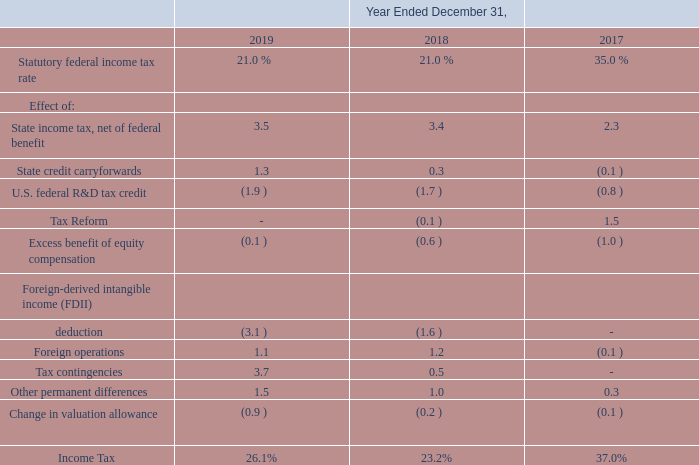We present below a summary of the items that cause recorded income taxes to differ from taxes computed using the statutory
federal income tax rate for the years ended December 31, 2019, 2018 and 2017:
On December 22, 2017, the United States enacted tax reform legislation commonly known as the Tax Cuts and Jobs Act (“the Act”), resulting in significant modifications to existing law. In December 2017, we recorded a provisional estimate of $3.3 million for the one-time deemed repatriation transition tax on unrepatriated foreign earnings. The provisional amount was based on information available at that time, including estimated tax earnings and profits from foreign investments. In the fourth quarter of 2018, we finalized our transition tax calculation and recorded additional tax expense of $0.3 million. In December 2017, we also recorded a provisional write-down to deferred tax assets of $0.7 million related to changes in Section 162(m), Internal Revenue Code of 1986, regarding deductions for excessive employee compensation. In 2018, we finalized our calculation under Section 162(m) and recorded a tax benefit of $0.5 million. We also recorded a one-time tax benefit in December 2017 of $1.2 million from the remeasurement of deferred tax assets and liabilities from 35% to 21%. As of December 31, 2018, we completed the accounting for all of the impacts of the Act. Act”), resulting in significant modifications to existing law. In December 2017, we recorded a provisional estimate of $3.3 million for the one-time deemed repatriation transition tax on unrepatriated foreign earnings. The provisional amount was based on information available at that time, including estimated tax earnings and profits from foreign investments. In the fourth quarter of 2018, we finalized our transition tax calculation and recorded additional tax expense of $0.3 million. In December 2017, we also recorded a provisional write-down to deferred tax assets of $0.7 million related to changes in Section 162(m), Internal Revenue Code of 1986, regarding deductions for excessive employee compensation. In 2018, we finalized our calculation under Section 162(m) and recorded a tax benefit of $0.5 million. We also recorded a one-time tax benefit in December 2017 of $1.2 million from the remeasurement of deferred tax assets and liabilities from 35% to 21%. As of December 31, 2018, we completed the accounting for all of the impacts of the Act.
Act”), resulting in significant modifications to existing law. In December 2017, we recorded a provisional estimate of $3.3 million for
the one-time deemed repatriation transition tax on unrepatriated foreign earnings. The provisional amount was based on information
available at that time, including estimated tax earnings and profits from foreign investments. In the fourth quarter of 2018, we
finalized our transition tax calculation and recorded additional tax expense of $0.3 million. In December 2017, we also recorded a
provisional write-down to deferred tax assets of $0.7 million related to changes in Section 162(m), Internal Revenue Code of 1986,
regarding deductions for excessive employee compensation. In 2018, we finalized our calculation under Section 162(m) and recorded
a tax benefit of $0.5 million. We also recorded a one-time tax benefit in December 2017 of $1.2 million from the remeasurement of
deferred tax assets and liabilities from 35% to 21%. As of December 31, 2018, we completed the accounting for all of the impacts of
the Act.
The Act provides for the global intangible low-taxed income (“GILTI”) provision which requires us in our U.S. income tax return, to include foreign subsidiary earnings in excess of an allowable return on the foreign subsidiary’s tangible assets. The FASB staff provided additional guidance to address the accounting for the effects of the provisions related to the taxation of GILTI, noting that companies should make an accounting policy election to recognize deferred taxes for temporary basis differences expected to reverse as GILTI in future years or to include the tax expense in the year it is incurred. We have elected to include the tax expense in the year that we incur it.
What is the statutory tax rate for 2017?
Answer scale should be: percent. 35.0. What is the amount for repatriation transition tax in 2017? $3.3 million. What is the change caused by the global intangible low-taxed income provision? Requires us in our u.s. income tax return, to include foreign subsidiary earnings in excess of an allowable return on the foreign subsidiary’s tangible assets. What is the change in the income tax rates between 2019 and 2018?
Answer scale should be: percent. 26.1%-23.2%
Answer: 2.9. What is the change in foreign operation tax between 2019 and 2018?
Answer scale should be: percent. 1.2-1.1
Answer: 0.1. Which year has the highest Statutory federal income tax rate? 35.0> 21.0
Answer: 2017. 